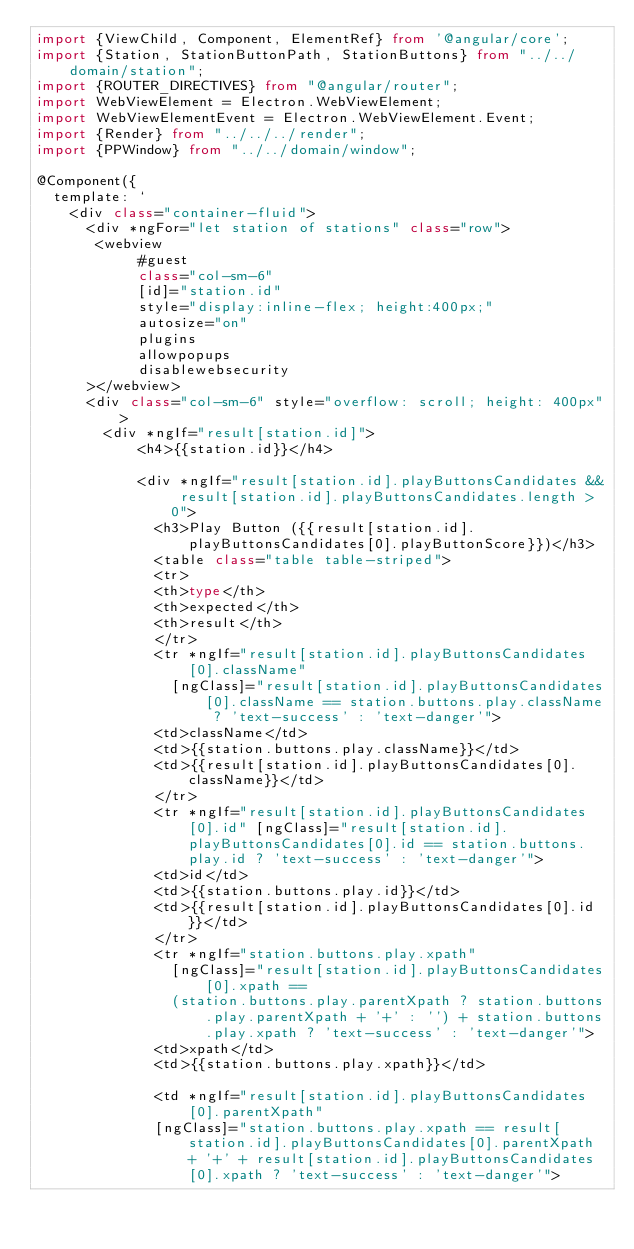<code> <loc_0><loc_0><loc_500><loc_500><_TypeScript_>import {ViewChild, Component, ElementRef} from '@angular/core';
import {Station, StationButtonPath, StationButtons} from "../../domain/station";
import {ROUTER_DIRECTIVES} from "@angular/router";
import WebViewElement = Electron.WebViewElement;
import WebViewElementEvent = Electron.WebViewElement.Event;
import {Render} from "../../../render";
import {PPWindow} from "../../domain/window";

@Component({
  template: `
    <div class="container-fluid">
      <div *ngFor="let station of stations" class="row">
       <webview    
            #guest
            class="col-sm-6"
            [id]="station.id"
            style="display:inline-flex; height:400px;"
            autosize="on"
            plugins
            allowpopups
            disablewebsecurity
      ></webview>
      <div class="col-sm-6" style="overflow: scroll; height: 400px">
        <div *ngIf="result[station.id]">
            <h4>{{station.id}}</h4>
            
            <div *ngIf="result[station.id].playButtonsCandidates && result[station.id].playButtonsCandidates.length > 0">
              <h3>Play Button ({{result[station.id].playButtonsCandidates[0].playButtonScore}})</h3>
              <table class="table table-striped">
              <tr>
              <th>type</th>
              <th>expected</th>
              <th>result</th>
              </tr>
              <tr *ngIf="result[station.id].playButtonsCandidates[0].className" 
                [ngClass]="result[station.id].playButtonsCandidates[0].className == station.buttons.play.className ? 'text-success' : 'text-danger'">
              <td>className</td>
              <td>{{station.buttons.play.className}}</td>
              <td>{{result[station.id].playButtonsCandidates[0].className}}</td>
              </tr>
              <tr *ngIf="result[station.id].playButtonsCandidates[0].id" [ngClass]="result[station.id].playButtonsCandidates[0].id == station.buttons.play.id ? 'text-success' : 'text-danger'">
              <td>id</td>
              <td>{{station.buttons.play.id}}</td>
              <td>{{result[station.id].playButtonsCandidates[0].id}}</td>
              </tr>
              <tr *ngIf="station.buttons.play.xpath" 
                [ngClass]="result[station.id].playButtonsCandidates[0].xpath == 
                (station.buttons.play.parentXpath ? station.buttons.play.parentXpath + '+' : '') + station.buttons.play.xpath ? 'text-success' : 'text-danger'">
              <td>xpath</td>
              <td>{{station.buttons.play.xpath}}</td>
              
              <td *ngIf="result[station.id].playButtonsCandidates[0].parentXpath"
              [ngClass]="station.buttons.play.xpath == result[station.id].playButtonsCandidates[0].parentXpath + '+' + result[station.id].playButtonsCandidates[0].xpath ? 'text-success' : 'text-danger'"></code> 